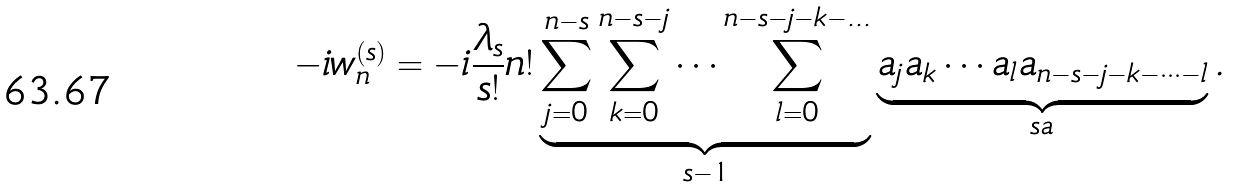<formula> <loc_0><loc_0><loc_500><loc_500>- i w ^ { ( s ) } _ { n } & = - i \frac { \lambda _ { s } } { s ! } n ! \underbrace { \sum _ { j = 0 } ^ { n - s } \sum _ { k = 0 } ^ { n - s - j } \cdots \sum _ { l = 0 } ^ { n - s - j - k - \dots } } _ { s - 1 } \underbrace { a _ { j } a _ { k } \cdots a _ { l } a _ { n - s - j - k - \dots - l } } _ { s a } .</formula> 